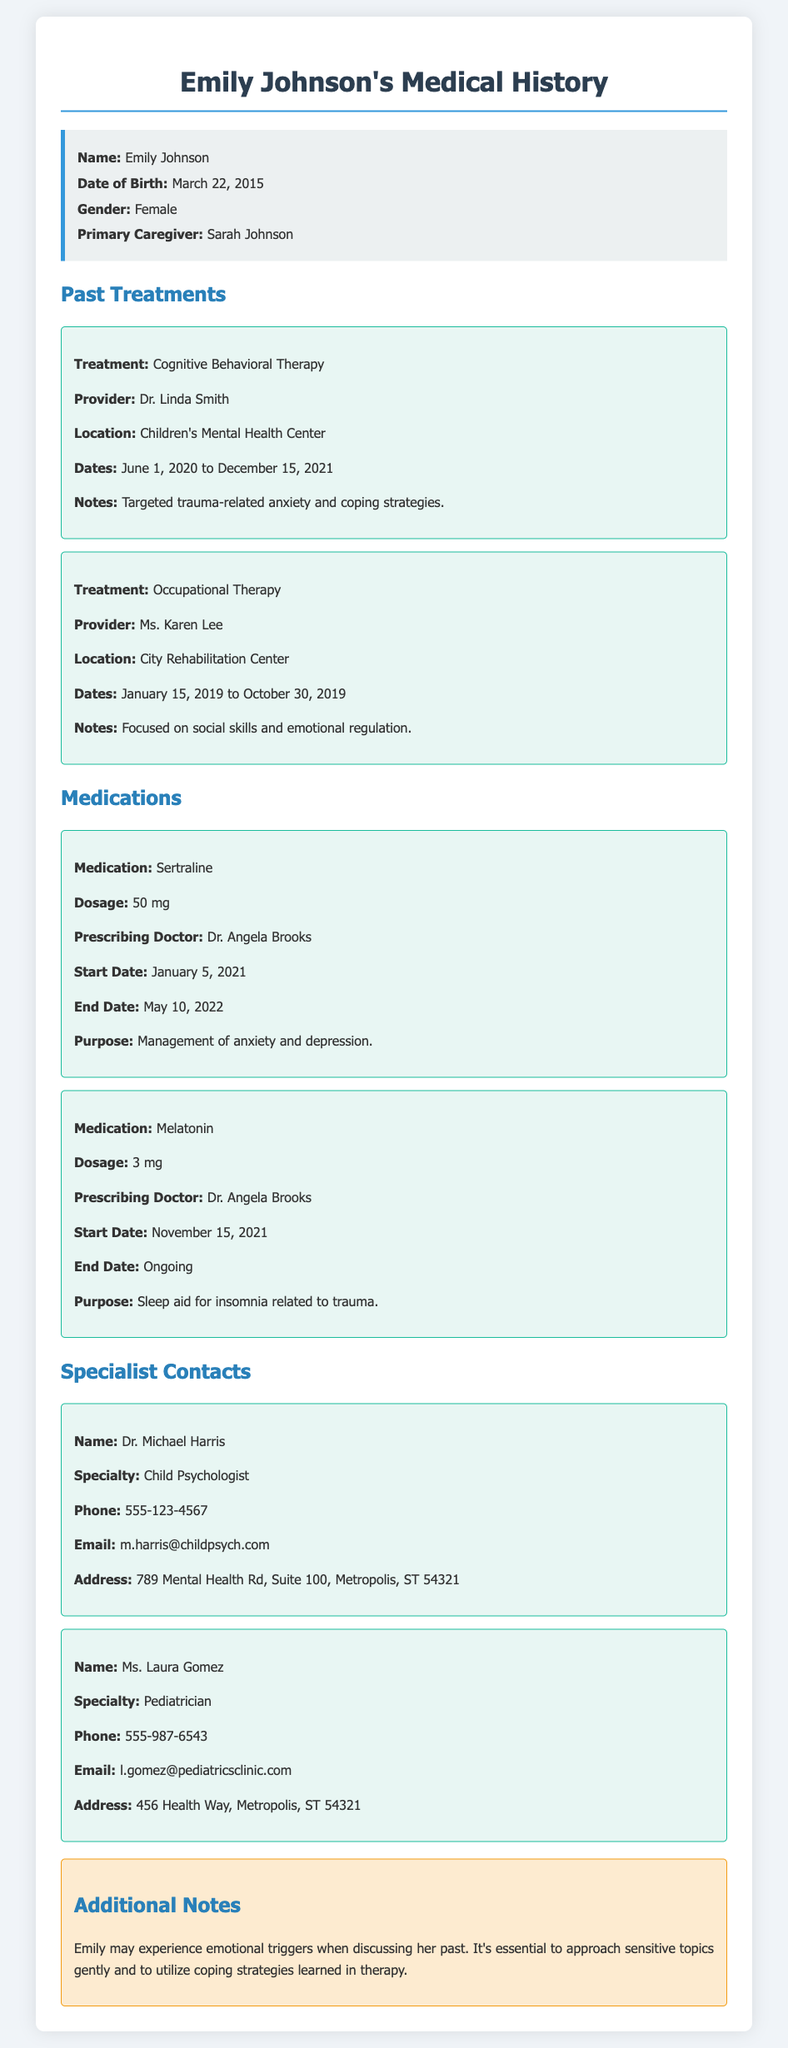What is the name of the child? The child's name is specified in the document as "Emily Johnson."
Answer: Emily Johnson What is Emily's date of birth? The date of birth is explicitly mentioned in the document as "March 22, 2015."
Answer: March 22, 2015 Who was the prescriber of Sertraline? The document states that "Dr. Angela Brooks" is the prescribing doctor for Sertraline.
Answer: Dr. Angela Brooks What type of therapy did Emily undergo from June 2020 to December 2021? The document details "Cognitive Behavioral Therapy" as the type of therapy during that period.
Answer: Cognitive Behavioral Therapy How long did Emily receive Occupational Therapy? The document indicates that Occupational Therapy lasted from "January 15, 2019 to October 30, 2019."
Answer: January 15, 2019 to October 30, 2019 What is the address of Emily's pediatrician? The document provides the address as "456 Health Way, Metropolis, ST 54321."
Answer: 456 Health Way, Metropolis, ST 54321 What is the purpose of Melatonin? The document states the purpose of Melatonin is as a "sleep aid for insomnia related to trauma."
Answer: sleep aid for insomnia related to trauma What should be considered when discussing Emily's past? The document notes that "Emily may experience emotional triggers" and suggests to approach these discussions gently.
Answer: emotional triggers What is the start date of Emily's Melatonin medication? The document specifies that Melatonin started on "November 15, 2021."
Answer: November 15, 2021 